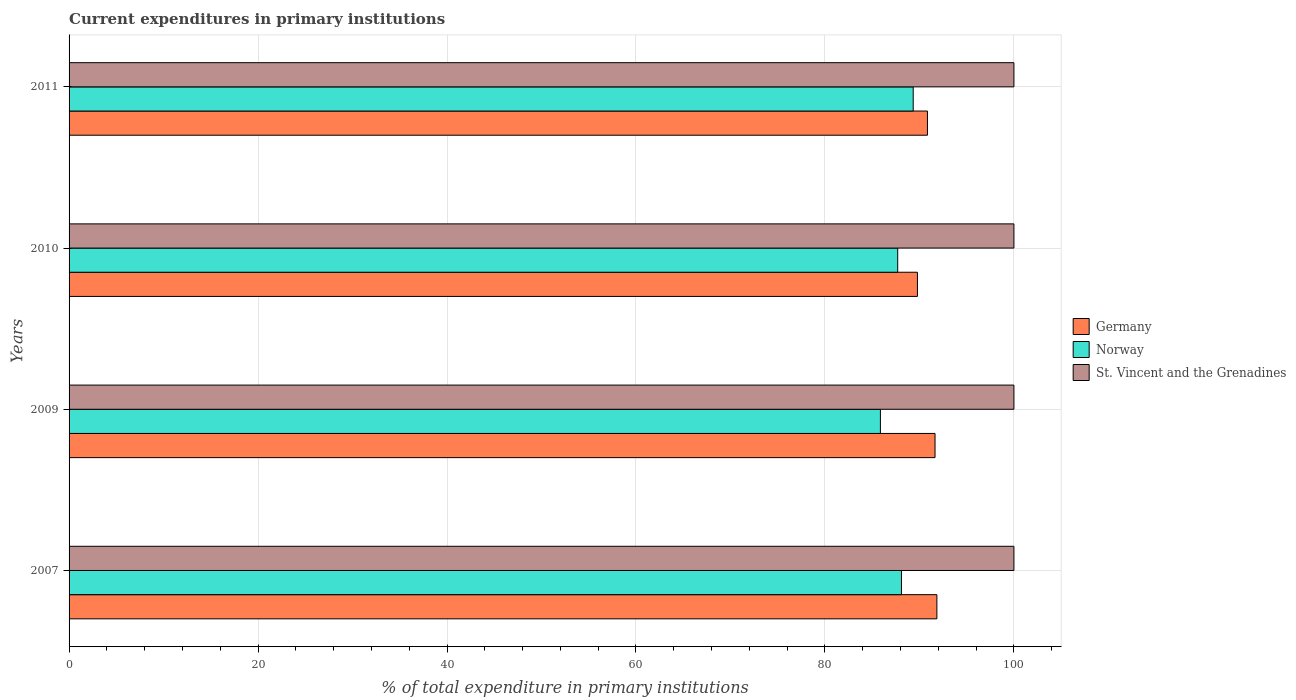How many different coloured bars are there?
Your answer should be very brief. 3. Are the number of bars on each tick of the Y-axis equal?
Your answer should be very brief. Yes. How many bars are there on the 2nd tick from the top?
Offer a very short reply. 3. How many bars are there on the 2nd tick from the bottom?
Your response must be concise. 3. What is the label of the 3rd group of bars from the top?
Your answer should be compact. 2009. What is the current expenditures in primary institutions in Germany in 2009?
Provide a succinct answer. 91.65. Across all years, what is the maximum current expenditures in primary institutions in Norway?
Your response must be concise. 89.34. Across all years, what is the minimum current expenditures in primary institutions in Germany?
Give a very brief answer. 89.79. In which year was the current expenditures in primary institutions in Germany minimum?
Offer a very short reply. 2010. What is the total current expenditures in primary institutions in Germany in the graph?
Ensure brevity in your answer.  364.14. What is the difference between the current expenditures in primary institutions in Germany in 2009 and the current expenditures in primary institutions in St. Vincent and the Grenadines in 2007?
Give a very brief answer. -8.35. In the year 2010, what is the difference between the current expenditures in primary institutions in St. Vincent and the Grenadines and current expenditures in primary institutions in Norway?
Offer a terse response. 12.3. In how many years, is the current expenditures in primary institutions in Germany greater than 28 %?
Your answer should be very brief. 4. What is the ratio of the current expenditures in primary institutions in Germany in 2009 to that in 2011?
Provide a succinct answer. 1.01. Is the difference between the current expenditures in primary institutions in St. Vincent and the Grenadines in 2010 and 2011 greater than the difference between the current expenditures in primary institutions in Norway in 2010 and 2011?
Make the answer very short. Yes. What is the difference between the highest and the second highest current expenditures in primary institutions in Norway?
Ensure brevity in your answer.  1.24. Is the sum of the current expenditures in primary institutions in Germany in 2007 and 2011 greater than the maximum current expenditures in primary institutions in Norway across all years?
Make the answer very short. Yes. What does the 2nd bar from the top in 2007 represents?
Your answer should be compact. Norway. What does the 3rd bar from the bottom in 2010 represents?
Offer a very short reply. St. Vincent and the Grenadines. Is it the case that in every year, the sum of the current expenditures in primary institutions in St. Vincent and the Grenadines and current expenditures in primary institutions in Germany is greater than the current expenditures in primary institutions in Norway?
Offer a terse response. Yes. How many bars are there?
Offer a very short reply. 12. How many years are there in the graph?
Give a very brief answer. 4. Are the values on the major ticks of X-axis written in scientific E-notation?
Your answer should be very brief. No. Does the graph contain grids?
Ensure brevity in your answer.  Yes. How are the legend labels stacked?
Provide a short and direct response. Vertical. What is the title of the graph?
Keep it short and to the point. Current expenditures in primary institutions. What is the label or title of the X-axis?
Make the answer very short. % of total expenditure in primary institutions. What is the % of total expenditure in primary institutions in Germany in 2007?
Offer a terse response. 91.85. What is the % of total expenditure in primary institutions of Norway in 2007?
Make the answer very short. 88.1. What is the % of total expenditure in primary institutions of St. Vincent and the Grenadines in 2007?
Ensure brevity in your answer.  100. What is the % of total expenditure in primary institutions in Germany in 2009?
Give a very brief answer. 91.65. What is the % of total expenditure in primary institutions of Norway in 2009?
Give a very brief answer. 85.87. What is the % of total expenditure in primary institutions in Germany in 2010?
Your answer should be very brief. 89.79. What is the % of total expenditure in primary institutions of Norway in 2010?
Your answer should be very brief. 87.7. What is the % of total expenditure in primary institutions of Germany in 2011?
Make the answer very short. 90.85. What is the % of total expenditure in primary institutions in Norway in 2011?
Make the answer very short. 89.34. Across all years, what is the maximum % of total expenditure in primary institutions of Germany?
Make the answer very short. 91.85. Across all years, what is the maximum % of total expenditure in primary institutions of Norway?
Provide a short and direct response. 89.34. Across all years, what is the maximum % of total expenditure in primary institutions of St. Vincent and the Grenadines?
Offer a very short reply. 100. Across all years, what is the minimum % of total expenditure in primary institutions of Germany?
Your response must be concise. 89.79. Across all years, what is the minimum % of total expenditure in primary institutions in Norway?
Your answer should be very brief. 85.87. What is the total % of total expenditure in primary institutions of Germany in the graph?
Offer a terse response. 364.14. What is the total % of total expenditure in primary institutions in Norway in the graph?
Your response must be concise. 351.01. What is the difference between the % of total expenditure in primary institutions of Germany in 2007 and that in 2009?
Your response must be concise. 0.2. What is the difference between the % of total expenditure in primary institutions in Norway in 2007 and that in 2009?
Provide a succinct answer. 2.23. What is the difference between the % of total expenditure in primary institutions in St. Vincent and the Grenadines in 2007 and that in 2009?
Offer a very short reply. 0. What is the difference between the % of total expenditure in primary institutions of Germany in 2007 and that in 2010?
Provide a short and direct response. 2.06. What is the difference between the % of total expenditure in primary institutions in Norway in 2007 and that in 2010?
Your answer should be very brief. 0.4. What is the difference between the % of total expenditure in primary institutions in St. Vincent and the Grenadines in 2007 and that in 2010?
Your response must be concise. 0. What is the difference between the % of total expenditure in primary institutions in Norway in 2007 and that in 2011?
Make the answer very short. -1.24. What is the difference between the % of total expenditure in primary institutions of St. Vincent and the Grenadines in 2007 and that in 2011?
Offer a terse response. 0. What is the difference between the % of total expenditure in primary institutions of Germany in 2009 and that in 2010?
Provide a succinct answer. 1.86. What is the difference between the % of total expenditure in primary institutions in Norway in 2009 and that in 2010?
Your answer should be compact. -1.83. What is the difference between the % of total expenditure in primary institutions in Germany in 2009 and that in 2011?
Offer a very short reply. 0.8. What is the difference between the % of total expenditure in primary institutions in Norway in 2009 and that in 2011?
Ensure brevity in your answer.  -3.47. What is the difference between the % of total expenditure in primary institutions of Germany in 2010 and that in 2011?
Provide a short and direct response. -1.06. What is the difference between the % of total expenditure in primary institutions of Norway in 2010 and that in 2011?
Provide a short and direct response. -1.64. What is the difference between the % of total expenditure in primary institutions in Germany in 2007 and the % of total expenditure in primary institutions in Norway in 2009?
Keep it short and to the point. 5.98. What is the difference between the % of total expenditure in primary institutions of Germany in 2007 and the % of total expenditure in primary institutions of St. Vincent and the Grenadines in 2009?
Your response must be concise. -8.15. What is the difference between the % of total expenditure in primary institutions in Norway in 2007 and the % of total expenditure in primary institutions in St. Vincent and the Grenadines in 2009?
Your response must be concise. -11.9. What is the difference between the % of total expenditure in primary institutions of Germany in 2007 and the % of total expenditure in primary institutions of Norway in 2010?
Make the answer very short. 4.15. What is the difference between the % of total expenditure in primary institutions of Germany in 2007 and the % of total expenditure in primary institutions of St. Vincent and the Grenadines in 2010?
Your answer should be very brief. -8.15. What is the difference between the % of total expenditure in primary institutions of Norway in 2007 and the % of total expenditure in primary institutions of St. Vincent and the Grenadines in 2010?
Your answer should be compact. -11.9. What is the difference between the % of total expenditure in primary institutions of Germany in 2007 and the % of total expenditure in primary institutions of Norway in 2011?
Make the answer very short. 2.51. What is the difference between the % of total expenditure in primary institutions of Germany in 2007 and the % of total expenditure in primary institutions of St. Vincent and the Grenadines in 2011?
Provide a short and direct response. -8.15. What is the difference between the % of total expenditure in primary institutions in Norway in 2007 and the % of total expenditure in primary institutions in St. Vincent and the Grenadines in 2011?
Your answer should be compact. -11.9. What is the difference between the % of total expenditure in primary institutions in Germany in 2009 and the % of total expenditure in primary institutions in Norway in 2010?
Provide a short and direct response. 3.95. What is the difference between the % of total expenditure in primary institutions in Germany in 2009 and the % of total expenditure in primary institutions in St. Vincent and the Grenadines in 2010?
Ensure brevity in your answer.  -8.35. What is the difference between the % of total expenditure in primary institutions of Norway in 2009 and the % of total expenditure in primary institutions of St. Vincent and the Grenadines in 2010?
Your answer should be compact. -14.13. What is the difference between the % of total expenditure in primary institutions in Germany in 2009 and the % of total expenditure in primary institutions in Norway in 2011?
Offer a very short reply. 2.31. What is the difference between the % of total expenditure in primary institutions in Germany in 2009 and the % of total expenditure in primary institutions in St. Vincent and the Grenadines in 2011?
Offer a terse response. -8.35. What is the difference between the % of total expenditure in primary institutions of Norway in 2009 and the % of total expenditure in primary institutions of St. Vincent and the Grenadines in 2011?
Keep it short and to the point. -14.13. What is the difference between the % of total expenditure in primary institutions of Germany in 2010 and the % of total expenditure in primary institutions of Norway in 2011?
Make the answer very short. 0.45. What is the difference between the % of total expenditure in primary institutions in Germany in 2010 and the % of total expenditure in primary institutions in St. Vincent and the Grenadines in 2011?
Offer a terse response. -10.21. What is the difference between the % of total expenditure in primary institutions in Norway in 2010 and the % of total expenditure in primary institutions in St. Vincent and the Grenadines in 2011?
Give a very brief answer. -12.3. What is the average % of total expenditure in primary institutions of Germany per year?
Ensure brevity in your answer.  91.03. What is the average % of total expenditure in primary institutions of Norway per year?
Offer a terse response. 87.75. In the year 2007, what is the difference between the % of total expenditure in primary institutions in Germany and % of total expenditure in primary institutions in Norway?
Your response must be concise. 3.75. In the year 2007, what is the difference between the % of total expenditure in primary institutions in Germany and % of total expenditure in primary institutions in St. Vincent and the Grenadines?
Offer a terse response. -8.15. In the year 2007, what is the difference between the % of total expenditure in primary institutions in Norway and % of total expenditure in primary institutions in St. Vincent and the Grenadines?
Give a very brief answer. -11.9. In the year 2009, what is the difference between the % of total expenditure in primary institutions of Germany and % of total expenditure in primary institutions of Norway?
Ensure brevity in your answer.  5.78. In the year 2009, what is the difference between the % of total expenditure in primary institutions in Germany and % of total expenditure in primary institutions in St. Vincent and the Grenadines?
Provide a succinct answer. -8.35. In the year 2009, what is the difference between the % of total expenditure in primary institutions in Norway and % of total expenditure in primary institutions in St. Vincent and the Grenadines?
Keep it short and to the point. -14.13. In the year 2010, what is the difference between the % of total expenditure in primary institutions of Germany and % of total expenditure in primary institutions of Norway?
Make the answer very short. 2.09. In the year 2010, what is the difference between the % of total expenditure in primary institutions of Germany and % of total expenditure in primary institutions of St. Vincent and the Grenadines?
Provide a short and direct response. -10.21. In the year 2010, what is the difference between the % of total expenditure in primary institutions in Norway and % of total expenditure in primary institutions in St. Vincent and the Grenadines?
Provide a short and direct response. -12.3. In the year 2011, what is the difference between the % of total expenditure in primary institutions in Germany and % of total expenditure in primary institutions in Norway?
Ensure brevity in your answer.  1.51. In the year 2011, what is the difference between the % of total expenditure in primary institutions of Germany and % of total expenditure in primary institutions of St. Vincent and the Grenadines?
Offer a very short reply. -9.15. In the year 2011, what is the difference between the % of total expenditure in primary institutions of Norway and % of total expenditure in primary institutions of St. Vincent and the Grenadines?
Make the answer very short. -10.66. What is the ratio of the % of total expenditure in primary institutions of Norway in 2007 to that in 2009?
Offer a very short reply. 1.03. What is the ratio of the % of total expenditure in primary institutions of Germany in 2007 to that in 2010?
Keep it short and to the point. 1.02. What is the ratio of the % of total expenditure in primary institutions in St. Vincent and the Grenadines in 2007 to that in 2010?
Keep it short and to the point. 1. What is the ratio of the % of total expenditure in primary institutions in Norway in 2007 to that in 2011?
Give a very brief answer. 0.99. What is the ratio of the % of total expenditure in primary institutions of St. Vincent and the Grenadines in 2007 to that in 2011?
Your answer should be very brief. 1. What is the ratio of the % of total expenditure in primary institutions in Germany in 2009 to that in 2010?
Give a very brief answer. 1.02. What is the ratio of the % of total expenditure in primary institutions in Norway in 2009 to that in 2010?
Make the answer very short. 0.98. What is the ratio of the % of total expenditure in primary institutions in St. Vincent and the Grenadines in 2009 to that in 2010?
Offer a very short reply. 1. What is the ratio of the % of total expenditure in primary institutions of Germany in 2009 to that in 2011?
Your response must be concise. 1.01. What is the ratio of the % of total expenditure in primary institutions of Norway in 2009 to that in 2011?
Keep it short and to the point. 0.96. What is the ratio of the % of total expenditure in primary institutions of Germany in 2010 to that in 2011?
Offer a terse response. 0.99. What is the ratio of the % of total expenditure in primary institutions in Norway in 2010 to that in 2011?
Ensure brevity in your answer.  0.98. What is the difference between the highest and the second highest % of total expenditure in primary institutions of Germany?
Keep it short and to the point. 0.2. What is the difference between the highest and the second highest % of total expenditure in primary institutions of Norway?
Your response must be concise. 1.24. What is the difference between the highest and the lowest % of total expenditure in primary institutions of Germany?
Your response must be concise. 2.06. What is the difference between the highest and the lowest % of total expenditure in primary institutions in Norway?
Provide a short and direct response. 3.47. 